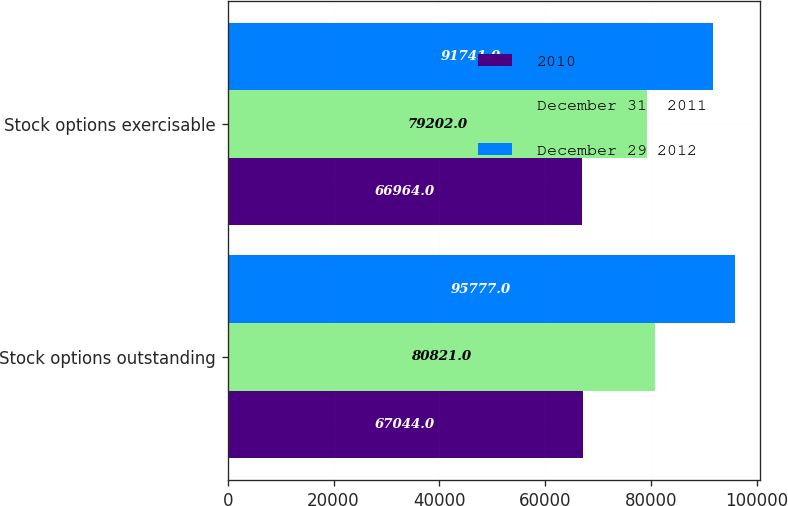Convert chart to OTSL. <chart><loc_0><loc_0><loc_500><loc_500><stacked_bar_chart><ecel><fcel>Stock options outstanding<fcel>Stock options exercisable<nl><fcel>2010<fcel>67044<fcel>66964<nl><fcel>December 31  2011<fcel>80821<fcel>79202<nl><fcel>December 29 2012<fcel>95777<fcel>91741<nl></chart> 